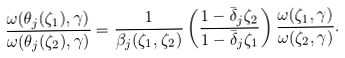Convert formula to latex. <formula><loc_0><loc_0><loc_500><loc_500>\frac { \omega ( \theta _ { j } ( \zeta _ { 1 } ) , \gamma ) } { \omega ( \theta _ { j } ( \zeta _ { 2 } ) , \gamma ) } = \frac { 1 } { \beta _ { j } ( \zeta _ { 1 } , \zeta _ { 2 } ) } \left ( \frac { 1 - \bar { \delta } _ { j } \zeta _ { 2 } } { 1 - \bar { \delta } _ { j } \zeta _ { 1 } } \right ) \frac { \omega ( \zeta _ { 1 } , \gamma ) } { \omega ( \zeta _ { 2 } , \gamma ) } .</formula> 